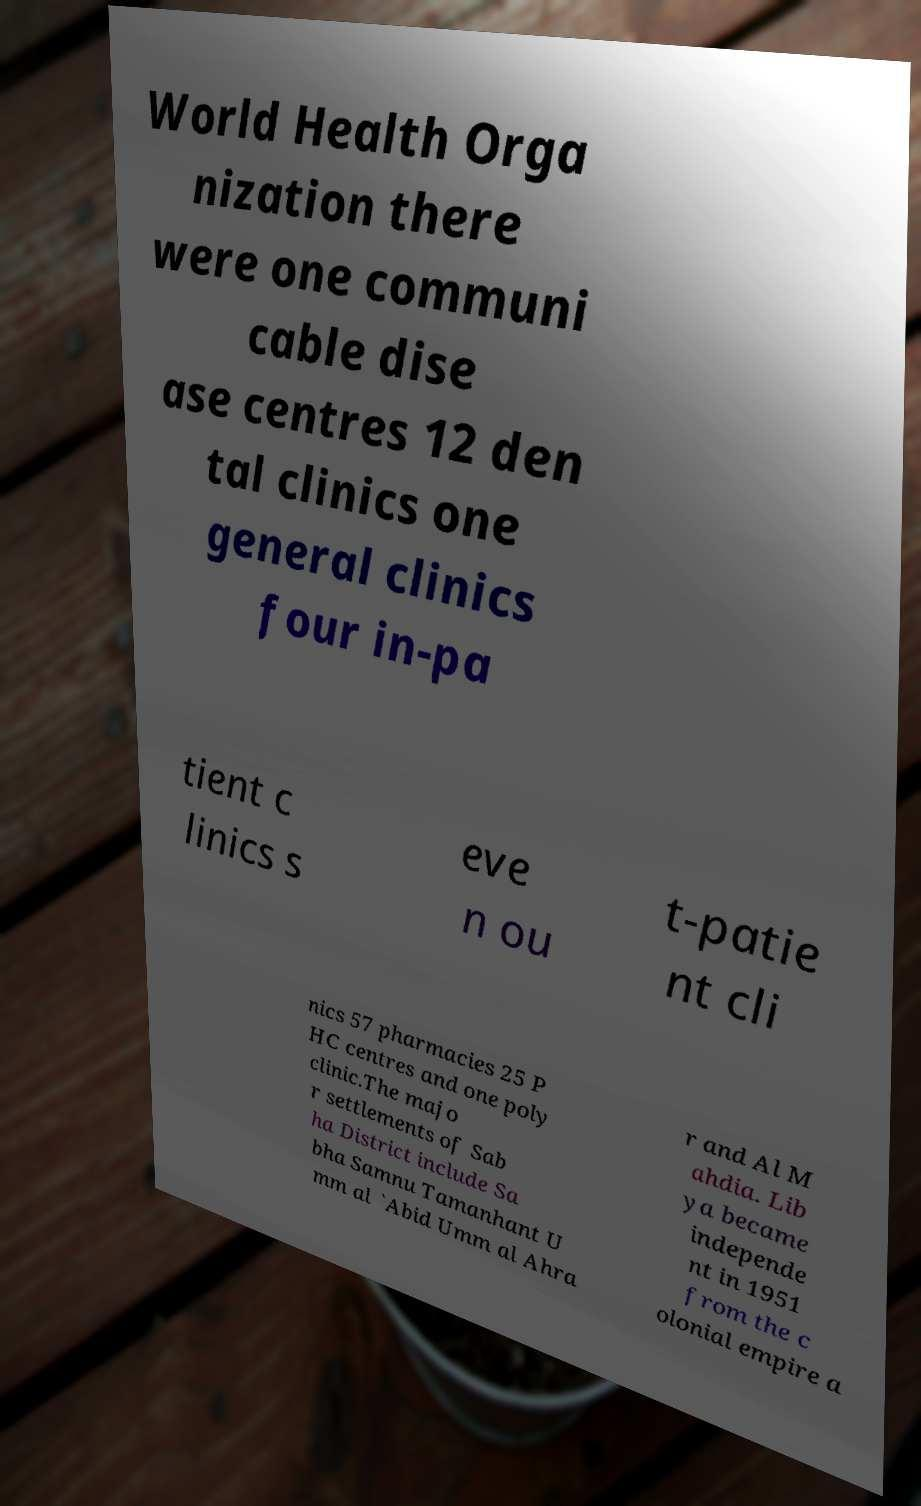Can you read and provide the text displayed in the image?This photo seems to have some interesting text. Can you extract and type it out for me? World Health Orga nization there were one communi cable dise ase centres 12 den tal clinics one general clinics four in-pa tient c linics s eve n ou t-patie nt cli nics 57 pharmacies 25 P HC centres and one poly clinic.The majo r settlements of Sab ha District include Sa bha Samnu Tamanhant U mm al `Abid Umm al Ahra r and Al M ahdia. Lib ya became independe nt in 1951 from the c olonial empire a 